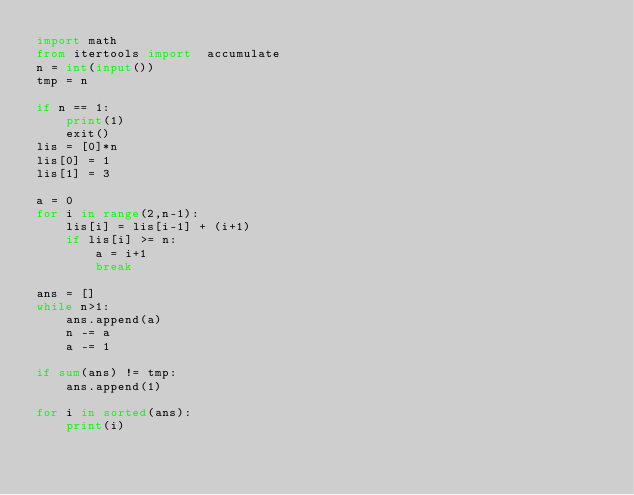<code> <loc_0><loc_0><loc_500><loc_500><_Python_>import math
from itertools import  accumulate
n = int(input())
tmp = n

if n == 1:
    print(1)
    exit()
lis = [0]*n
lis[0] = 1
lis[1] = 3

a = 0
for i in range(2,n-1):
    lis[i] = lis[i-1] + (i+1)
    if lis[i] >= n:
        a = i+1
        break

ans = []
while n>1:
    ans.append(a)
    n -= a
    a -= 1

if sum(ans) != tmp:
    ans.append(1)

for i in sorted(ans):
    print(i)

</code> 